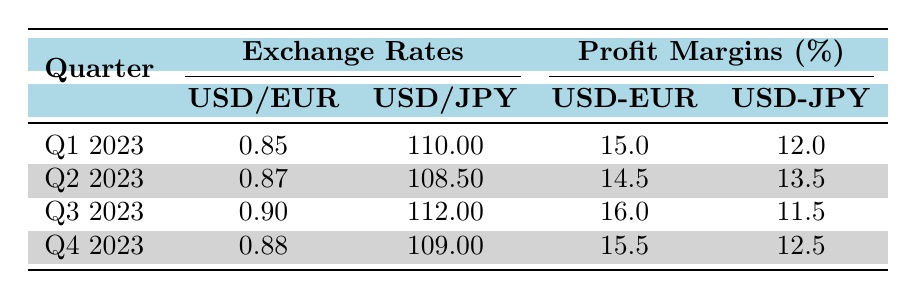What is the profit margin for USD to EUR in Q3 2023? The table shows that for Q3 2023, the profit margin associated with USD to EUR is listed in the column for profit margins under USD-EUR. Specifically, the value is 16.0.
Answer: 16.0 What was the USD to JPY exchange rate in Q2 2023? According to the data in the table, the USD to JPY exchange rate for Q2 2023 is provided in the corresponding column, which shows a value of 108.50.
Answer: 108.50 Is the profit margin for USD to JPY greater than for USD to EUR in Q4 2023? In Q4 2023, the profit margin for USD to JPY is listed as 12.5%, and for USD to EUR it is 15.5%. Since 15.5 is greater than 12.5, the profit margin for USD to JPY is not greater than for USD to EUR. Therefore, the answer is no.
Answer: No What is the average profit margin for USD to EUR across all quarters? First, we add the profit margins for USD to EUR from all quarters: (15.0 + 14.5 + 16.0 + 15.5) = 61.0. Next, we divide that sum by the number of quarters (4): 61.0 / 4 = 15.25. Hence, the average profit margin for USD to EUR across all quarters is 15.25.
Answer: 15.25 What was the highest USD to EUR exchange rate recorded in the table? By looking at the USD to EUR exchange rates across all quarters in the table, we identify the rates: 0.85, 0.87, 0.90, and 0.88. The highest value among these rates is 0.90 for Q3 2023.
Answer: 0.90 Was there a decrease in the profit margin for USD to JPY from Q1 to Q2 2023? The profit margins for USD to JPY in Q1 and Q2 2023 were 12.0% and 13.5% respectively. Since 13.5% is greater than 12.0%, it indicates that there was an increase, not a decrease, in the profit margin. Hence, the answer is no.
Answer: No What is the difference in profit margins for USD to EUR and USD to JPY in Q1 2023? For Q1 2023, the profit margin for USD to EUR is 15.0% and for USD to JPY, it is 12.0%. To find the difference, we subtract the profit margin for USD to JPY from that of USD to EUR: 15.0 - 12.0 = 3.0. Thus, the difference is 3.0.
Answer: 3.0 What was the trend in the USD to EUR exchange rate from Q1 to Q4 2023? The values for USD to EUR exchange rates from Q1 to Q4 2023 are 0.85, 0.87, 0.90, and 0.88 respectively. We can observe that the rate increased from Q1 (0.85) to Q3 (0.90) and then slightly decreased to 0.88 in Q4. Therefore, the trend shows an overall increase followed by a slight decrease.
Answer: Increase then slight decrease 